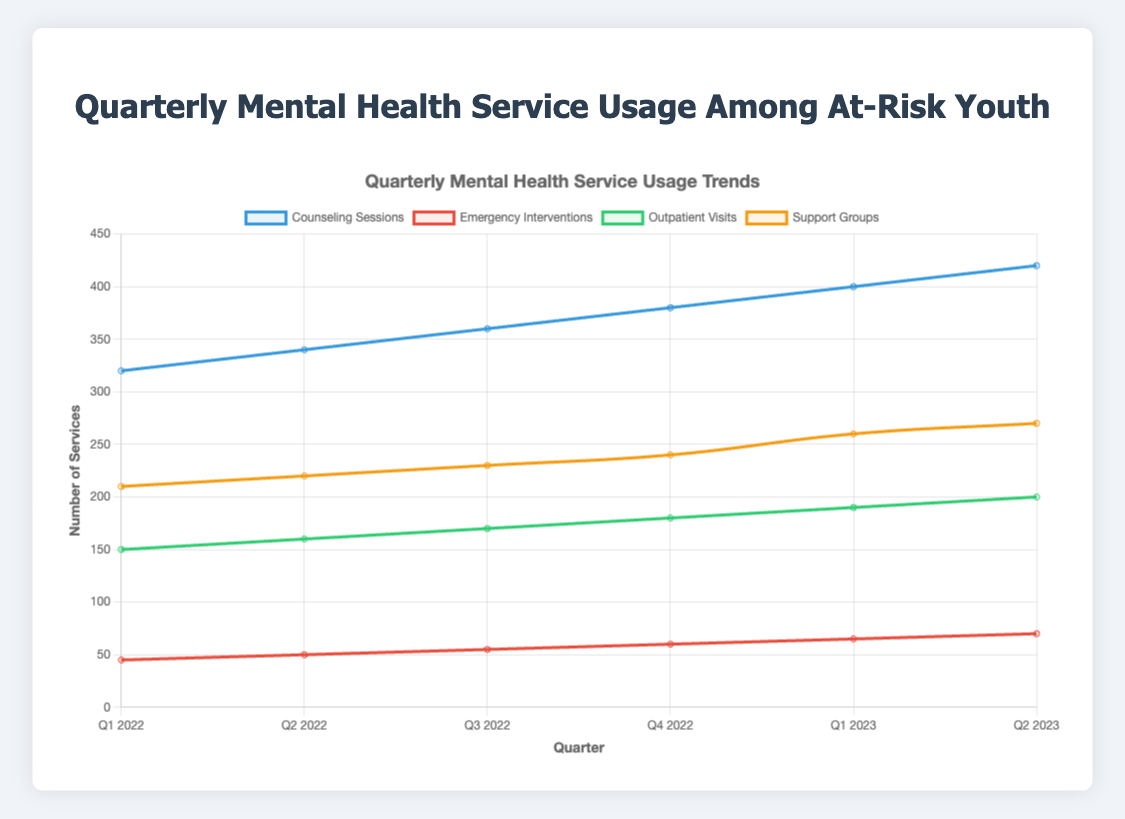What is the total number of Counseling Sessions and Emergency Interventions in Q1 2023? First, identify the number of Counseling Sessions in Q1 2023, which is 400. Then, identify the number of Emergency Interventions in Q1 2023, which is 65. Sum these two numbers: 400 + 65 = 465.
Answer: 465 Which service had the highest number of sessions in Q2 2023? Look at the data points for each service (Counseling Sessions, Emergency Interventions, Outpatient Visits, Support Groups) in Q2 2023 and compare the values. Counseling Sessions has the highest number with 420 sessions.
Answer: Counseling Sessions Between Q1 2022 and Q2 2023, how many times did the number of Outpatient Visits increase? Identify the number of Outpatient Visits in Q1 2022 (150) and Q2 2023 (200). Subtract the Q1 2022 value from the Q2 2023 value: 200 - 150 = 50, which indicates the increase.
Answer: 50 Which quarter saw the largest increase in Support Groups sessions compared to the previous quarter? Calculate the differences in Support Groups sessions between consecutive quarters: Q2 2022 - Q1 2022 = 220 - 210 = 10, Q3 2022 - Q2 2022 = 230 - 220 = 10, Q4 2022 - Q3 2022 = 240 - 230 = 10, Q1 2023 - Q4 2022 = 260 - 240 = 20, Q2 2023 - Q1 2023 = 270 - 260 = 10. The largest increase is between Q4 2022 and Q1 2023: 20 sessions.
Answer: Q1 2023 Is the trendline for Emergency Interventions generally increasing, decreasing, or stable? Observe the values of Emergency Interventions over the quarters: 45, 50, 55, 60, 65, 70. These values are increasing every quarter.
Answer: Increasing Which service had the lowest usage in Q4 2022? Look at the data points for each service (Counseling Sessions, Emergency Interventions, Outpatient Visits, Support Groups) in Q4 2022 and find the smallest value. Emergency Interventions has the lowest usage with 60 sessions.
Answer: Emergency Interventions What is the overall trend in Counseling Sessions from Q1 2022 to Q2 2023? Recall each data point for Counseling Sessions over the quarters: 320, 340, 360, 380, 400, 420. The values show a consistent increase over time.
Answer: Increasing 